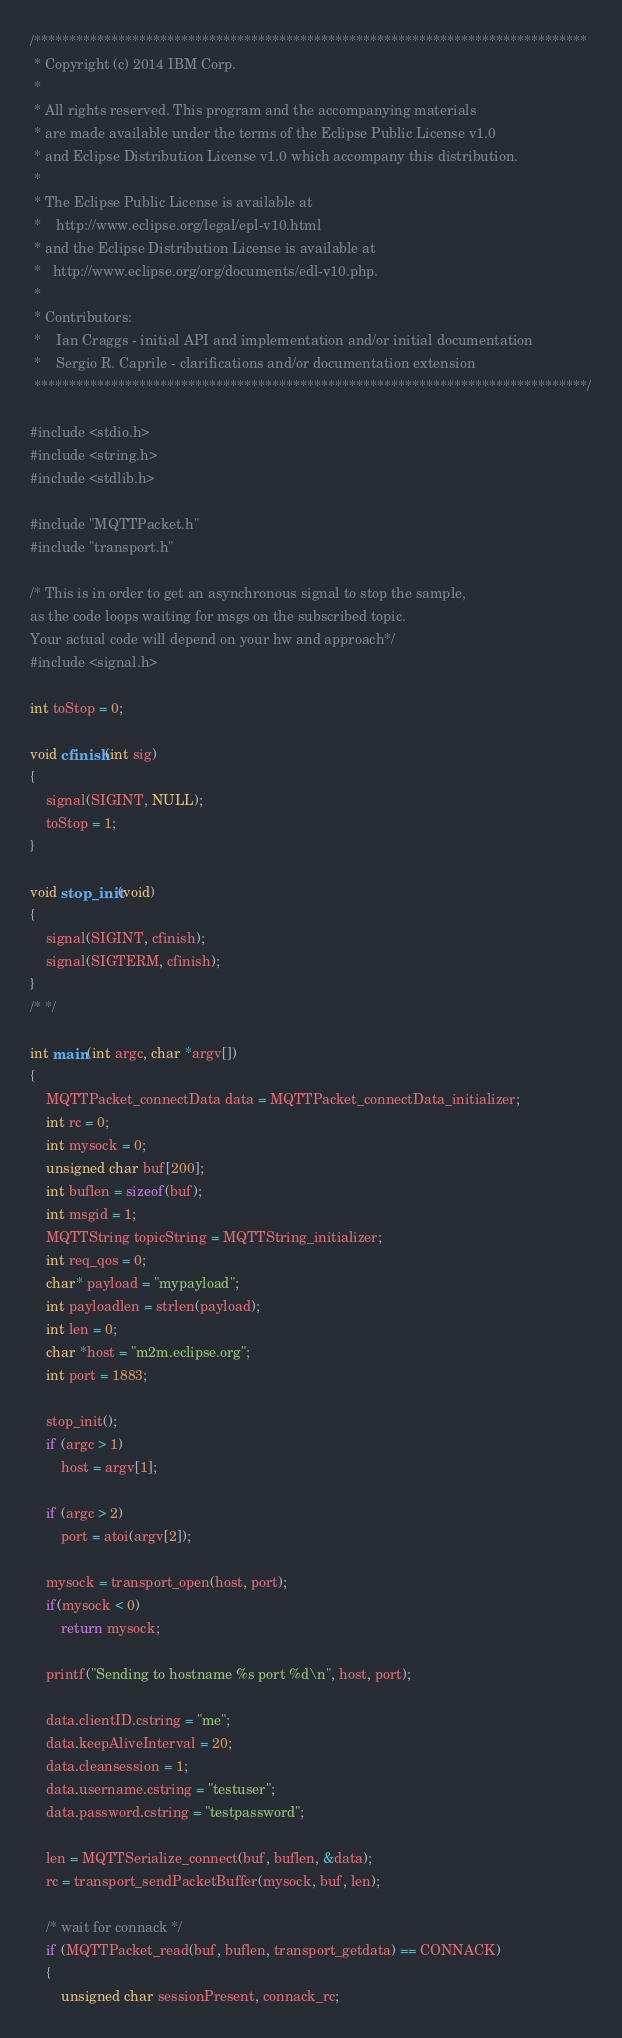Convert code to text. <code><loc_0><loc_0><loc_500><loc_500><_C_>/*******************************************************************************
 * Copyright (c) 2014 IBM Corp.
 *
 * All rights reserved. This program and the accompanying materials
 * are made available under the terms of the Eclipse Public License v1.0
 * and Eclipse Distribution License v1.0 which accompany this distribution.
 *
 * The Eclipse Public License is available at
 *    http://www.eclipse.org/legal/epl-v10.html
 * and the Eclipse Distribution License is available at
 *   http://www.eclipse.org/org/documents/edl-v10.php.
 *
 * Contributors:
 *    Ian Craggs - initial API and implementation and/or initial documentation
 *    Sergio R. Caprile - clarifications and/or documentation extension
 *******************************************************************************/

#include <stdio.h>
#include <string.h>
#include <stdlib.h>

#include "MQTTPacket.h"
#include "transport.h"

/* This is in order to get an asynchronous signal to stop the sample,
as the code loops waiting for msgs on the subscribed topic.
Your actual code will depend on your hw and approach*/
#include <signal.h>

int toStop = 0;

void cfinish(int sig)
{
	signal(SIGINT, NULL);
	toStop = 1;
}

void stop_init(void)
{
	signal(SIGINT, cfinish);
	signal(SIGTERM, cfinish);
}
/* */

int main(int argc, char *argv[])
{
	MQTTPacket_connectData data = MQTTPacket_connectData_initializer;
	int rc = 0;
	int mysock = 0;
	unsigned char buf[200];
	int buflen = sizeof(buf);
	int msgid = 1;
	MQTTString topicString = MQTTString_initializer;
	int req_qos = 0;
	char* payload = "mypayload";
	int payloadlen = strlen(payload);
	int len = 0;
	char *host = "m2m.eclipse.org";
	int port = 1883;

	stop_init();
	if (argc > 1)
		host = argv[1];

	if (argc > 2)
		port = atoi(argv[2]);

	mysock = transport_open(host, port);
	if(mysock < 0)
		return mysock;

	printf("Sending to hostname %s port %d\n", host, port);

	data.clientID.cstring = "me";
	data.keepAliveInterval = 20;
	data.cleansession = 1;
	data.username.cstring = "testuser";
	data.password.cstring = "testpassword";

	len = MQTTSerialize_connect(buf, buflen, &data);
	rc = transport_sendPacketBuffer(mysock, buf, len);

	/* wait for connack */
	if (MQTTPacket_read(buf, buflen, transport_getdata) == CONNACK)
	{
		unsigned char sessionPresent, connack_rc;
</code> 